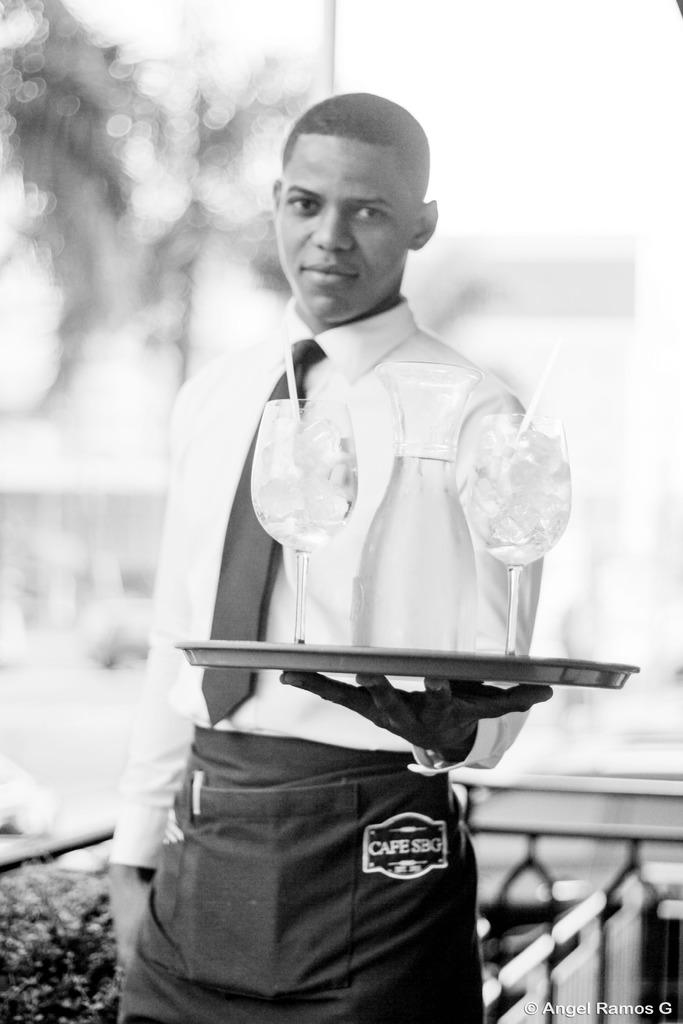What is the color scheme of the image? The image is black and white. Who is present in the image? There is a man in the image. What is the man holding in the image? The man is holding a tray. What is on the tray that the man is holding? The tray contains glasses. Can you describe the background of the image? The background of the image is blurred. Reasoning: Let'g: Let's think step by step in order to produce the conversation. We start by identifying the color scheme of the image, which is black and white. Then, we focus on the main subject in the image, which is the man. Next, we describe what the man is holding, which is a tray containing glasses. Finally, we mention the background of the image, which is blurred. Each question is designed to elicit a specific detail about the image that is known from the provided facts. Absurd Question/Answer: What type of roll is the man preparing in the image? There is no roll present in the image; the man is holding a tray with glasses. Is the man playing baseball in the image? There is no indication of baseball or any sports activity in the image. 